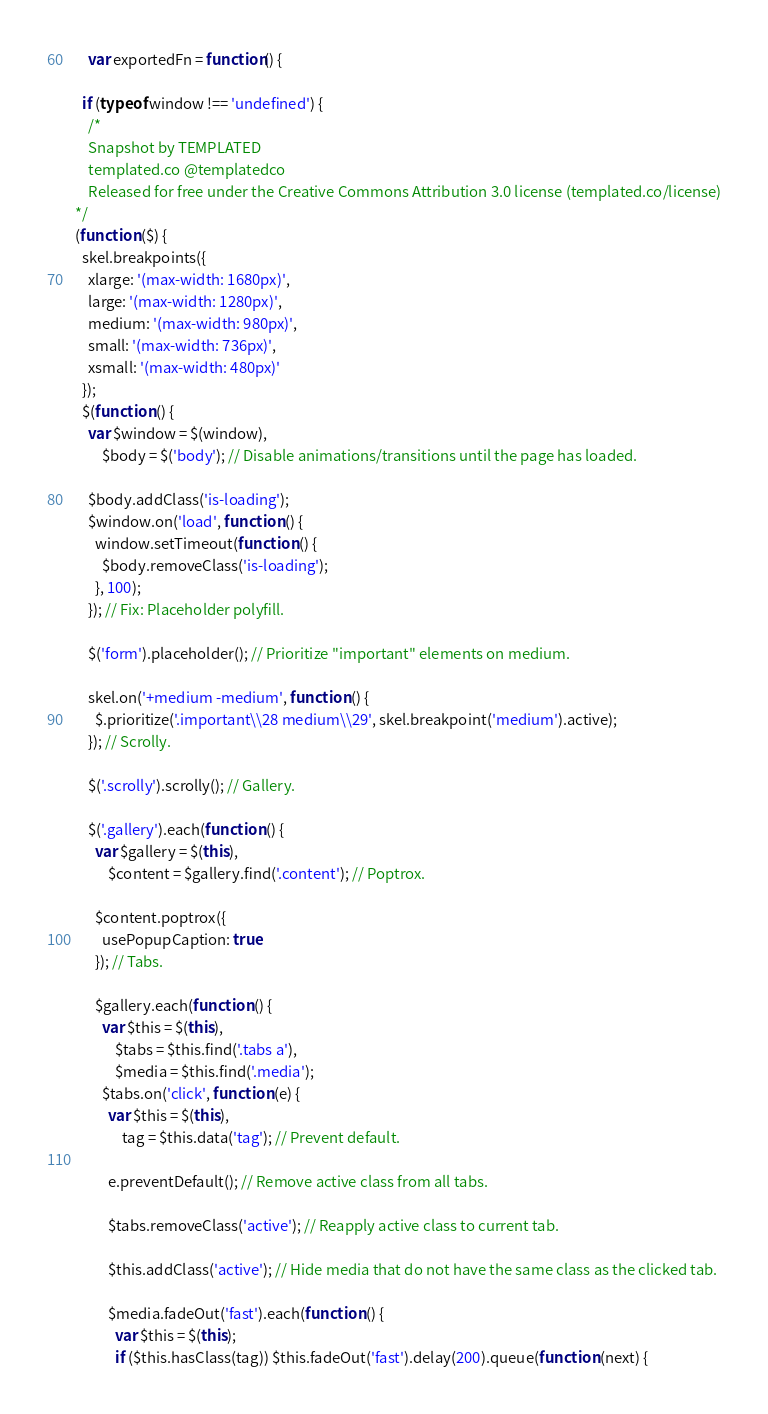<code> <loc_0><loc_0><loc_500><loc_500><_JavaScript_>
    var exportedFn = function() {
      
  if (typeof window !== 'undefined') {
    /*
	Snapshot by TEMPLATED
	templated.co @templatedco
	Released for free under the Creative Commons Attribution 3.0 license (templated.co/license)
*/
(function ($) {
  skel.breakpoints({
    xlarge: '(max-width: 1680px)',
    large: '(max-width: 1280px)',
    medium: '(max-width: 980px)',
    small: '(max-width: 736px)',
    xsmall: '(max-width: 480px)'
  });
  $(function () {
    var $window = $(window),
        $body = $('body'); // Disable animations/transitions until the page has loaded.

    $body.addClass('is-loading');
    $window.on('load', function () {
      window.setTimeout(function () {
        $body.removeClass('is-loading');
      }, 100);
    }); // Fix: Placeholder polyfill.

    $('form').placeholder(); // Prioritize "important" elements on medium.

    skel.on('+medium -medium', function () {
      $.prioritize('.important\\28 medium\\29', skel.breakpoint('medium').active);
    }); // Scrolly.

    $('.scrolly').scrolly(); // Gallery.

    $('.gallery').each(function () {
      var $gallery = $(this),
          $content = $gallery.find('.content'); // Poptrox.

      $content.poptrox({
        usePopupCaption: true
      }); // Tabs.

      $gallery.each(function () {
        var $this = $(this),
            $tabs = $this.find('.tabs a'),
            $media = $this.find('.media');
        $tabs.on('click', function (e) {
          var $this = $(this),
              tag = $this.data('tag'); // Prevent default.

          e.preventDefault(); // Remove active class from all tabs.

          $tabs.removeClass('active'); // Reapply active class to current tab.

          $this.addClass('active'); // Hide media that do not have the same class as the clicked tab.

          $media.fadeOut('fast').each(function () {
            var $this = $(this);
            if ($this.hasClass(tag)) $this.fadeOut('fast').delay(200).queue(function (next) {</code> 